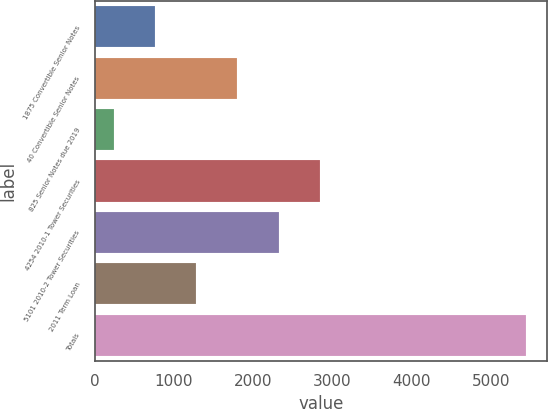Convert chart. <chart><loc_0><loc_0><loc_500><loc_500><bar_chart><fcel>1875 Convertible Senior Notes<fcel>40 Convertible Senior Notes<fcel>825 Senior Notes due 2019<fcel>4254 2010-1 Tower Securities<fcel>5101 2010-2 Tower Securities<fcel>2011 Term Loan<fcel>Totals<nl><fcel>763.43<fcel>1802.69<fcel>243.8<fcel>2841.95<fcel>2322.32<fcel>1283.06<fcel>5440.1<nl></chart> 